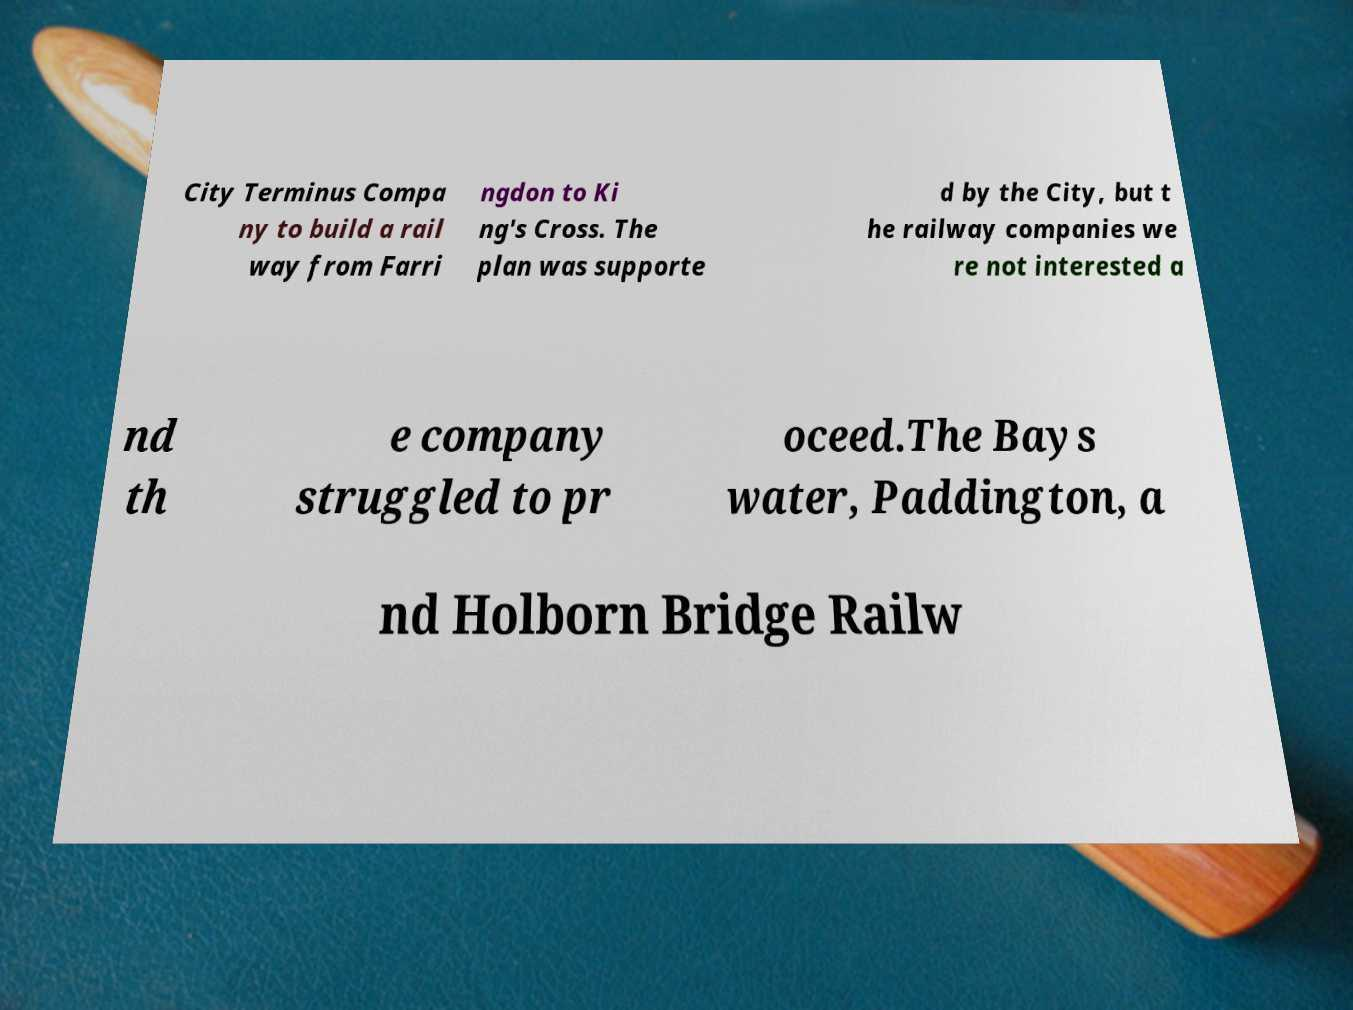For documentation purposes, I need the text within this image transcribed. Could you provide that? City Terminus Compa ny to build a rail way from Farri ngdon to Ki ng's Cross. The plan was supporte d by the City, but t he railway companies we re not interested a nd th e company struggled to pr oceed.The Bays water, Paddington, a nd Holborn Bridge Railw 